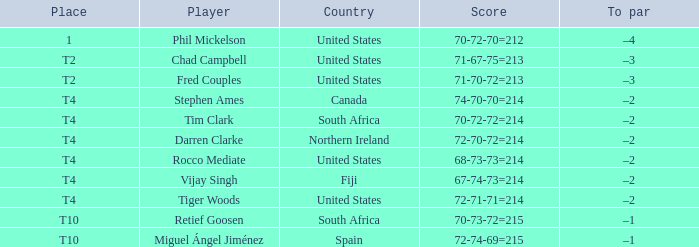What was the outcome for spain? 72-74-69=215. Parse the full table. {'header': ['Place', 'Player', 'Country', 'Score', 'To par'], 'rows': [['1', 'Phil Mickelson', 'United States', '70-72-70=212', '–4'], ['T2', 'Chad Campbell', 'United States', '71-67-75=213', '–3'], ['T2', 'Fred Couples', 'United States', '71-70-72=213', '–3'], ['T4', 'Stephen Ames', 'Canada', '74-70-70=214', '–2'], ['T4', 'Tim Clark', 'South Africa', '70-72-72=214', '–2'], ['T4', 'Darren Clarke', 'Northern Ireland', '72-70-72=214', '–2'], ['T4', 'Rocco Mediate', 'United States', '68-73-73=214', '–2'], ['T4', 'Vijay Singh', 'Fiji', '67-74-73=214', '–2'], ['T4', 'Tiger Woods', 'United States', '72-71-71=214', '–2'], ['T10', 'Retief Goosen', 'South Africa', '70-73-72=215', '–1'], ['T10', 'Miguel Ángel Jiménez', 'Spain', '72-74-69=215', '–1']]} 